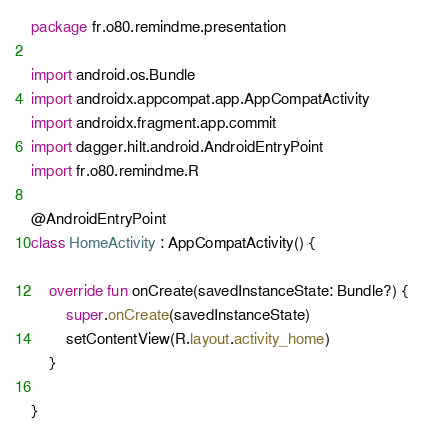Convert code to text. <code><loc_0><loc_0><loc_500><loc_500><_Kotlin_>package fr.o80.remindme.presentation

import android.os.Bundle
import androidx.appcompat.app.AppCompatActivity
import androidx.fragment.app.commit
import dagger.hilt.android.AndroidEntryPoint
import fr.o80.remindme.R

@AndroidEntryPoint
class HomeActivity : AppCompatActivity() {

    override fun onCreate(savedInstanceState: Bundle?) {
        super.onCreate(savedInstanceState)
        setContentView(R.layout.activity_home)
    }

}
</code> 